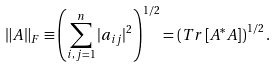Convert formula to latex. <formula><loc_0><loc_0><loc_500><loc_500>\left \| A \right \| _ { F } \equiv \left ( \sum _ { i , j = 1 } ^ { n } | a _ { i j } | ^ { 2 } \right ) ^ { 1 / 2 } = \left ( T r \left [ A ^ { * } A \right ] \right ) ^ { 1 / 2 } .</formula> 